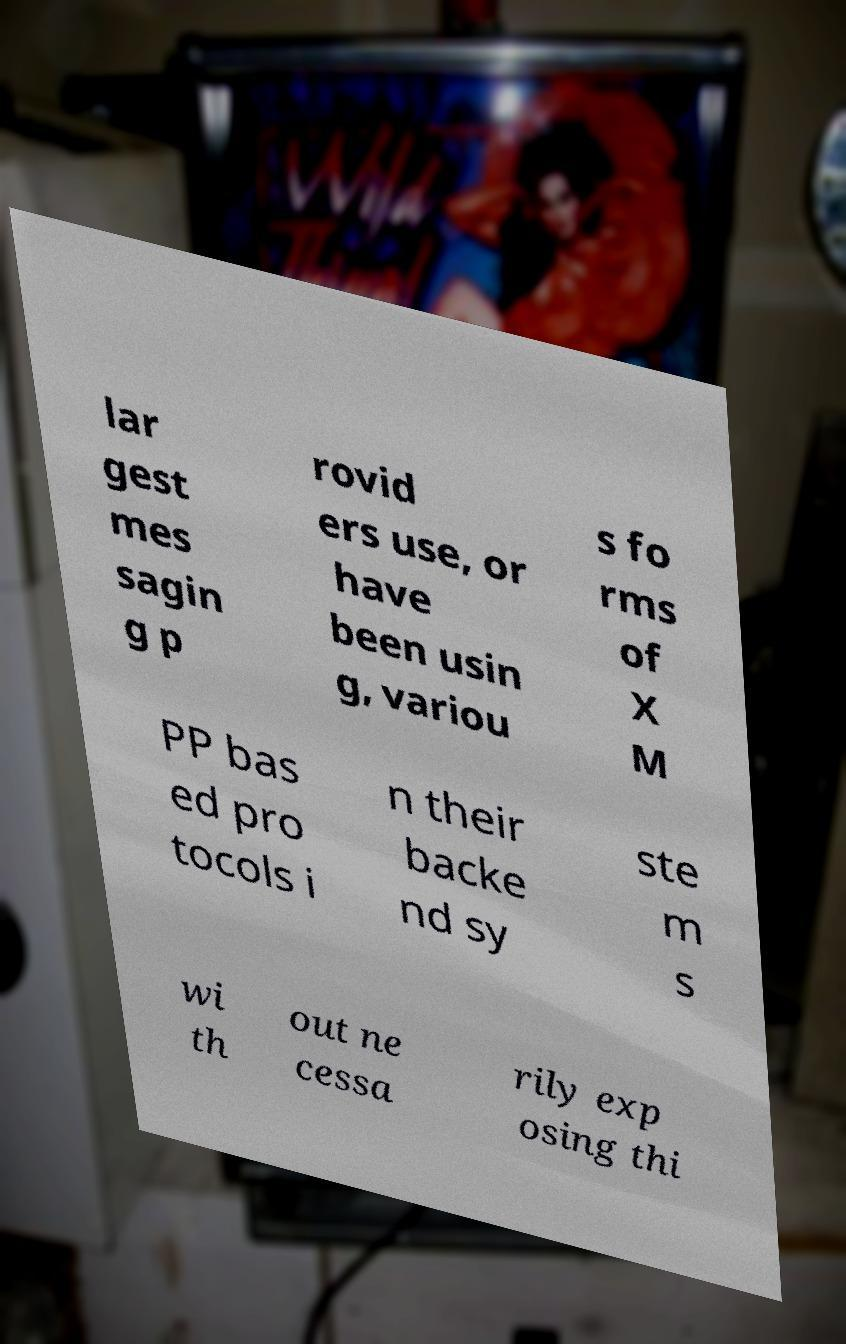There's text embedded in this image that I need extracted. Can you transcribe it verbatim? lar gest mes sagin g p rovid ers use, or have been usin g, variou s fo rms of X M PP bas ed pro tocols i n their backe nd sy ste m s wi th out ne cessa rily exp osing thi 